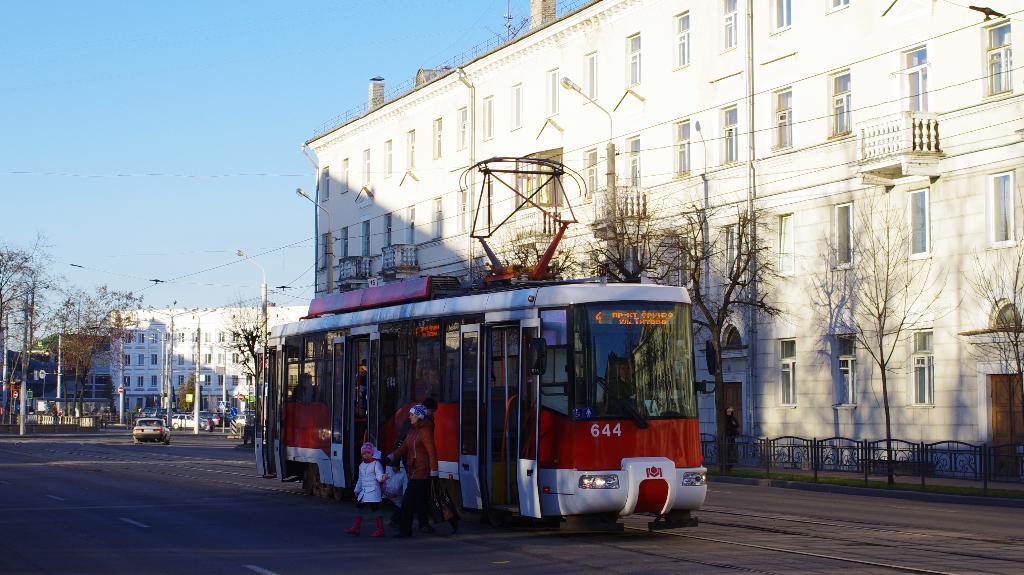Please provide a concise description of this image. This is a picture of an outside view, in this picture in the center there is one bus and some persons are walking. On the right side there is a building and some trees, fence, grass and a footpath. In the background there are some buildings, poles, trees, lights and wires. At the bottom there is road and on the road there are some vehicles, on the top of the image there is sky. 